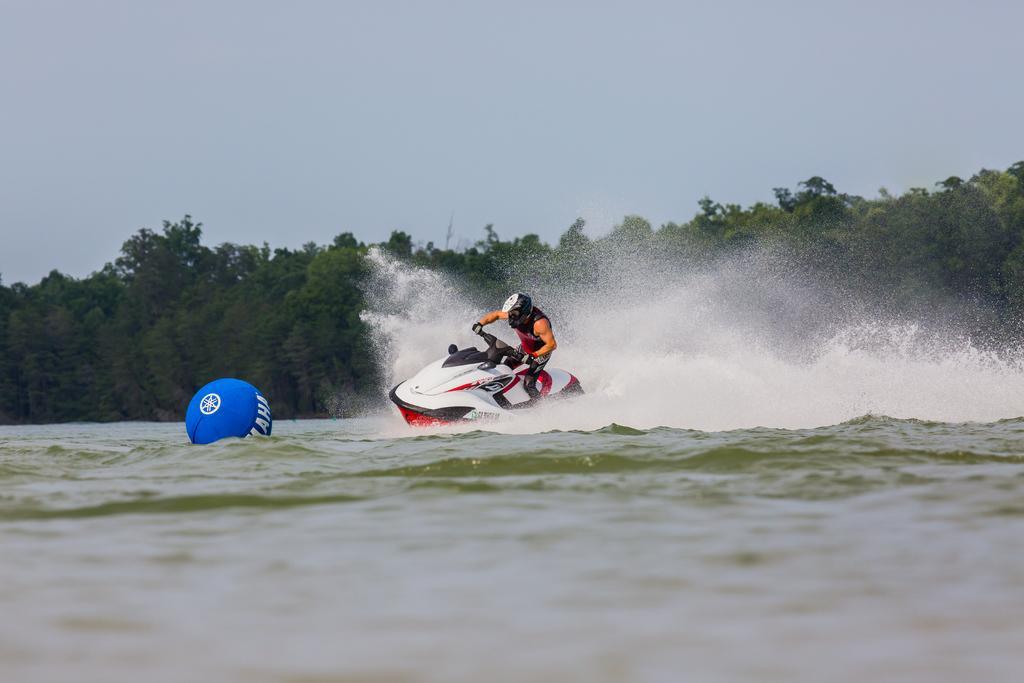Could you give a brief overview of what you see in this image? In this image we can see a person riding on the jet ski on the river, there is a ball with text on it, also we can see trees and the sky. 